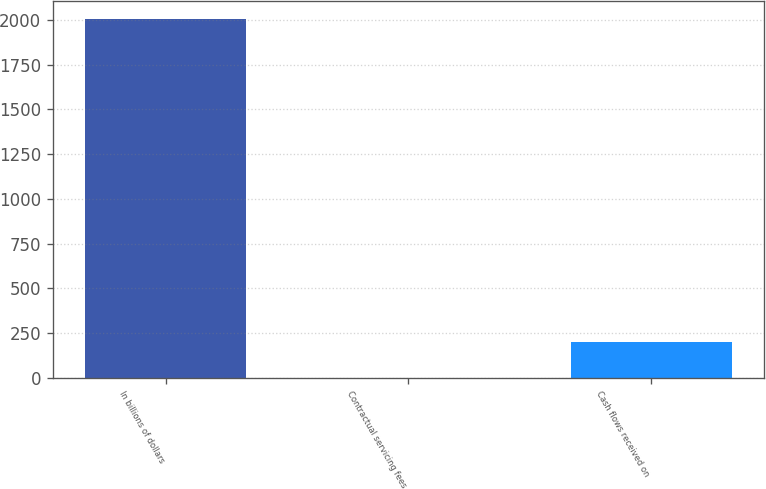Convert chart to OTSL. <chart><loc_0><loc_0><loc_500><loc_500><bar_chart><fcel>In billions of dollars<fcel>Contractual servicing fees<fcel>Cash flows received on<nl><fcel>2008<fcel>0.1<fcel>200.89<nl></chart> 